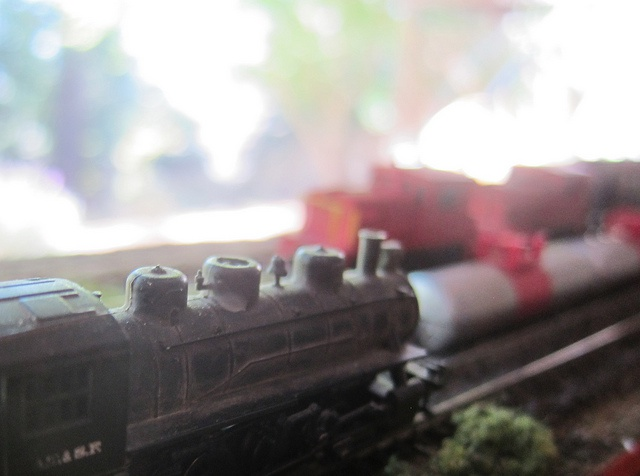Describe the objects in this image and their specific colors. I can see train in lightblue, black, gray, and darkgray tones and train in lightblue, brown, lightpink, and darkgray tones in this image. 